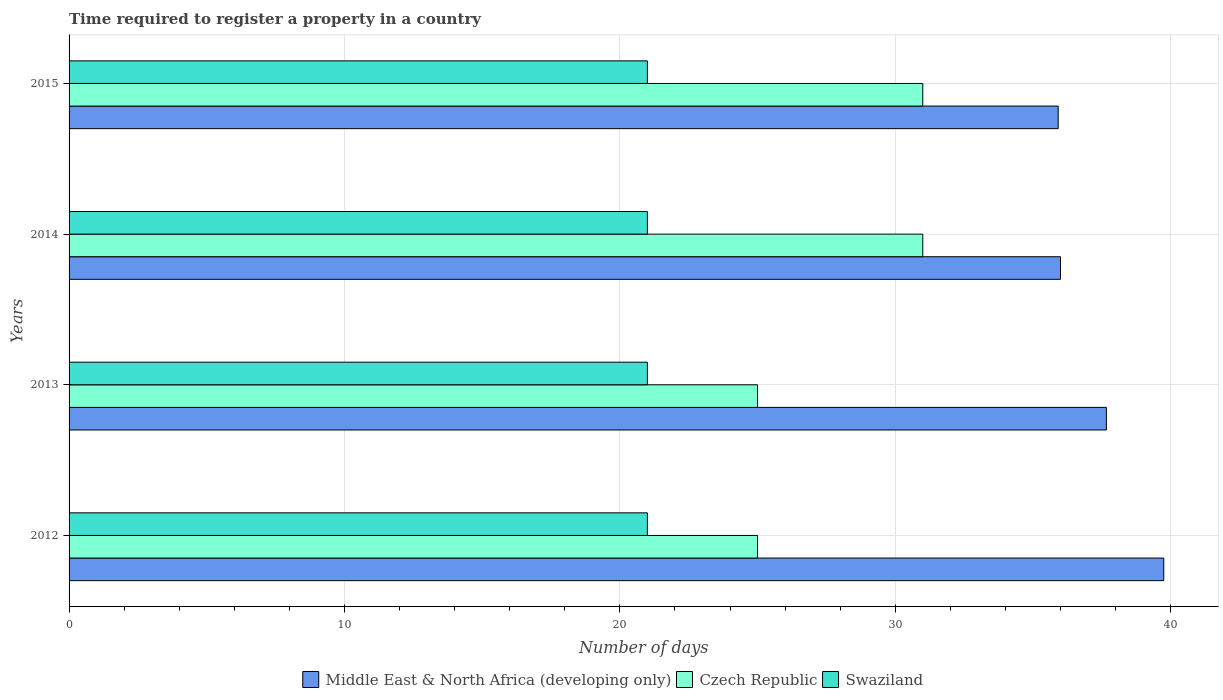Are the number of bars on each tick of the Y-axis equal?
Give a very brief answer. Yes. What is the label of the 1st group of bars from the top?
Your answer should be very brief. 2015. What is the number of days required to register a property in Czech Republic in 2015?
Keep it short and to the point. 31. Across all years, what is the maximum number of days required to register a property in Middle East & North Africa (developing only)?
Provide a short and direct response. 39.75. Across all years, what is the minimum number of days required to register a property in Middle East & North Africa (developing only)?
Ensure brevity in your answer.  35.92. In which year was the number of days required to register a property in Swaziland maximum?
Provide a short and direct response. 2012. In which year was the number of days required to register a property in Swaziland minimum?
Offer a terse response. 2012. What is the total number of days required to register a property in Middle East & North Africa (developing only) in the graph?
Provide a short and direct response. 149.33. What is the difference between the number of days required to register a property in Czech Republic in 2012 and that in 2015?
Give a very brief answer. -6. What is the difference between the number of days required to register a property in Middle East & North Africa (developing only) in 2013 and the number of days required to register a property in Swaziland in 2015?
Ensure brevity in your answer.  16.67. What is the average number of days required to register a property in Swaziland per year?
Your answer should be compact. 21. In the year 2012, what is the difference between the number of days required to register a property in Swaziland and number of days required to register a property in Middle East & North Africa (developing only)?
Your answer should be compact. -18.75. What is the ratio of the number of days required to register a property in Czech Republic in 2012 to that in 2015?
Offer a terse response. 0.81. Is the number of days required to register a property in Czech Republic in 2012 less than that in 2013?
Offer a terse response. No. What is the difference between the highest and the second highest number of days required to register a property in Czech Republic?
Ensure brevity in your answer.  0. What is the difference between the highest and the lowest number of days required to register a property in Middle East & North Africa (developing only)?
Provide a short and direct response. 3.83. What does the 2nd bar from the top in 2014 represents?
Give a very brief answer. Czech Republic. What does the 1st bar from the bottom in 2015 represents?
Your answer should be very brief. Middle East & North Africa (developing only). Is it the case that in every year, the sum of the number of days required to register a property in Swaziland and number of days required to register a property in Czech Republic is greater than the number of days required to register a property in Middle East & North Africa (developing only)?
Your answer should be very brief. Yes. How many bars are there?
Give a very brief answer. 12. Are all the bars in the graph horizontal?
Make the answer very short. Yes. How many years are there in the graph?
Your answer should be compact. 4. Does the graph contain any zero values?
Make the answer very short. No. Does the graph contain grids?
Give a very brief answer. Yes. Where does the legend appear in the graph?
Make the answer very short. Bottom center. How many legend labels are there?
Make the answer very short. 3. How are the legend labels stacked?
Give a very brief answer. Horizontal. What is the title of the graph?
Keep it short and to the point. Time required to register a property in a country. Does "Chad" appear as one of the legend labels in the graph?
Your answer should be very brief. No. What is the label or title of the X-axis?
Provide a succinct answer. Number of days. What is the label or title of the Y-axis?
Make the answer very short. Years. What is the Number of days of Middle East & North Africa (developing only) in 2012?
Give a very brief answer. 39.75. What is the Number of days of Czech Republic in 2012?
Your answer should be compact. 25. What is the Number of days of Middle East & North Africa (developing only) in 2013?
Your answer should be very brief. 37.67. What is the Number of days of Middle East & North Africa (developing only) in 2014?
Your answer should be compact. 36. What is the Number of days of Czech Republic in 2014?
Keep it short and to the point. 31. What is the Number of days in Middle East & North Africa (developing only) in 2015?
Your response must be concise. 35.92. Across all years, what is the maximum Number of days in Middle East & North Africa (developing only)?
Your answer should be compact. 39.75. Across all years, what is the maximum Number of days of Czech Republic?
Offer a very short reply. 31. Across all years, what is the maximum Number of days in Swaziland?
Ensure brevity in your answer.  21. Across all years, what is the minimum Number of days of Middle East & North Africa (developing only)?
Ensure brevity in your answer.  35.92. Across all years, what is the minimum Number of days in Swaziland?
Ensure brevity in your answer.  21. What is the total Number of days in Middle East & North Africa (developing only) in the graph?
Your answer should be compact. 149.33. What is the total Number of days in Czech Republic in the graph?
Offer a terse response. 112. What is the difference between the Number of days in Middle East & North Africa (developing only) in 2012 and that in 2013?
Keep it short and to the point. 2.08. What is the difference between the Number of days of Swaziland in 2012 and that in 2013?
Your response must be concise. 0. What is the difference between the Number of days of Middle East & North Africa (developing only) in 2012 and that in 2014?
Offer a terse response. 3.75. What is the difference between the Number of days in Czech Republic in 2012 and that in 2014?
Give a very brief answer. -6. What is the difference between the Number of days in Middle East & North Africa (developing only) in 2012 and that in 2015?
Your response must be concise. 3.83. What is the difference between the Number of days of Swaziland in 2012 and that in 2015?
Keep it short and to the point. 0. What is the difference between the Number of days of Middle East & North Africa (developing only) in 2013 and that in 2014?
Offer a very short reply. 1.67. What is the difference between the Number of days of Czech Republic in 2013 and that in 2014?
Your answer should be compact. -6. What is the difference between the Number of days in Swaziland in 2013 and that in 2014?
Offer a very short reply. 0. What is the difference between the Number of days in Middle East & North Africa (developing only) in 2014 and that in 2015?
Make the answer very short. 0.08. What is the difference between the Number of days of Czech Republic in 2014 and that in 2015?
Make the answer very short. 0. What is the difference between the Number of days of Swaziland in 2014 and that in 2015?
Make the answer very short. 0. What is the difference between the Number of days in Middle East & North Africa (developing only) in 2012 and the Number of days in Czech Republic in 2013?
Keep it short and to the point. 14.75. What is the difference between the Number of days of Middle East & North Africa (developing only) in 2012 and the Number of days of Swaziland in 2013?
Your response must be concise. 18.75. What is the difference between the Number of days in Middle East & North Africa (developing only) in 2012 and the Number of days in Czech Republic in 2014?
Offer a very short reply. 8.75. What is the difference between the Number of days of Middle East & North Africa (developing only) in 2012 and the Number of days of Swaziland in 2014?
Keep it short and to the point. 18.75. What is the difference between the Number of days of Middle East & North Africa (developing only) in 2012 and the Number of days of Czech Republic in 2015?
Your answer should be very brief. 8.75. What is the difference between the Number of days of Middle East & North Africa (developing only) in 2012 and the Number of days of Swaziland in 2015?
Offer a terse response. 18.75. What is the difference between the Number of days of Czech Republic in 2012 and the Number of days of Swaziland in 2015?
Provide a succinct answer. 4. What is the difference between the Number of days of Middle East & North Africa (developing only) in 2013 and the Number of days of Swaziland in 2014?
Your answer should be compact. 16.67. What is the difference between the Number of days in Czech Republic in 2013 and the Number of days in Swaziland in 2014?
Your response must be concise. 4. What is the difference between the Number of days of Middle East & North Africa (developing only) in 2013 and the Number of days of Czech Republic in 2015?
Your response must be concise. 6.67. What is the difference between the Number of days in Middle East & North Africa (developing only) in 2013 and the Number of days in Swaziland in 2015?
Provide a short and direct response. 16.67. What is the difference between the Number of days in Czech Republic in 2013 and the Number of days in Swaziland in 2015?
Offer a terse response. 4. What is the difference between the Number of days in Middle East & North Africa (developing only) in 2014 and the Number of days in Czech Republic in 2015?
Your answer should be very brief. 5. What is the difference between the Number of days of Middle East & North Africa (developing only) in 2014 and the Number of days of Swaziland in 2015?
Provide a short and direct response. 15. What is the difference between the Number of days in Czech Republic in 2014 and the Number of days in Swaziland in 2015?
Provide a short and direct response. 10. What is the average Number of days in Middle East & North Africa (developing only) per year?
Provide a short and direct response. 37.33. What is the average Number of days in Swaziland per year?
Your response must be concise. 21. In the year 2012, what is the difference between the Number of days of Middle East & North Africa (developing only) and Number of days of Czech Republic?
Provide a short and direct response. 14.75. In the year 2012, what is the difference between the Number of days in Middle East & North Africa (developing only) and Number of days in Swaziland?
Ensure brevity in your answer.  18.75. In the year 2013, what is the difference between the Number of days in Middle East & North Africa (developing only) and Number of days in Czech Republic?
Provide a succinct answer. 12.67. In the year 2013, what is the difference between the Number of days in Middle East & North Africa (developing only) and Number of days in Swaziland?
Your answer should be very brief. 16.67. In the year 2013, what is the difference between the Number of days in Czech Republic and Number of days in Swaziland?
Your answer should be compact. 4. In the year 2014, what is the difference between the Number of days in Middle East & North Africa (developing only) and Number of days in Czech Republic?
Your answer should be very brief. 5. In the year 2014, what is the difference between the Number of days of Middle East & North Africa (developing only) and Number of days of Swaziland?
Ensure brevity in your answer.  15. In the year 2015, what is the difference between the Number of days in Middle East & North Africa (developing only) and Number of days in Czech Republic?
Ensure brevity in your answer.  4.92. In the year 2015, what is the difference between the Number of days of Middle East & North Africa (developing only) and Number of days of Swaziland?
Provide a succinct answer. 14.92. In the year 2015, what is the difference between the Number of days of Czech Republic and Number of days of Swaziland?
Your answer should be very brief. 10. What is the ratio of the Number of days of Middle East & North Africa (developing only) in 2012 to that in 2013?
Your response must be concise. 1.06. What is the ratio of the Number of days of Middle East & North Africa (developing only) in 2012 to that in 2014?
Offer a terse response. 1.1. What is the ratio of the Number of days of Czech Republic in 2012 to that in 2014?
Your answer should be very brief. 0.81. What is the ratio of the Number of days in Swaziland in 2012 to that in 2014?
Keep it short and to the point. 1. What is the ratio of the Number of days in Middle East & North Africa (developing only) in 2012 to that in 2015?
Provide a short and direct response. 1.11. What is the ratio of the Number of days in Czech Republic in 2012 to that in 2015?
Provide a short and direct response. 0.81. What is the ratio of the Number of days in Swaziland in 2012 to that in 2015?
Your answer should be very brief. 1. What is the ratio of the Number of days in Middle East & North Africa (developing only) in 2013 to that in 2014?
Keep it short and to the point. 1.05. What is the ratio of the Number of days in Czech Republic in 2013 to that in 2014?
Make the answer very short. 0.81. What is the ratio of the Number of days in Swaziland in 2013 to that in 2014?
Ensure brevity in your answer.  1. What is the ratio of the Number of days in Middle East & North Africa (developing only) in 2013 to that in 2015?
Provide a succinct answer. 1.05. What is the ratio of the Number of days of Czech Republic in 2013 to that in 2015?
Offer a very short reply. 0.81. What is the ratio of the Number of days in Swaziland in 2014 to that in 2015?
Your answer should be very brief. 1. What is the difference between the highest and the second highest Number of days of Middle East & North Africa (developing only)?
Offer a terse response. 2.08. What is the difference between the highest and the lowest Number of days in Middle East & North Africa (developing only)?
Ensure brevity in your answer.  3.83. What is the difference between the highest and the lowest Number of days in Swaziland?
Your answer should be compact. 0. 